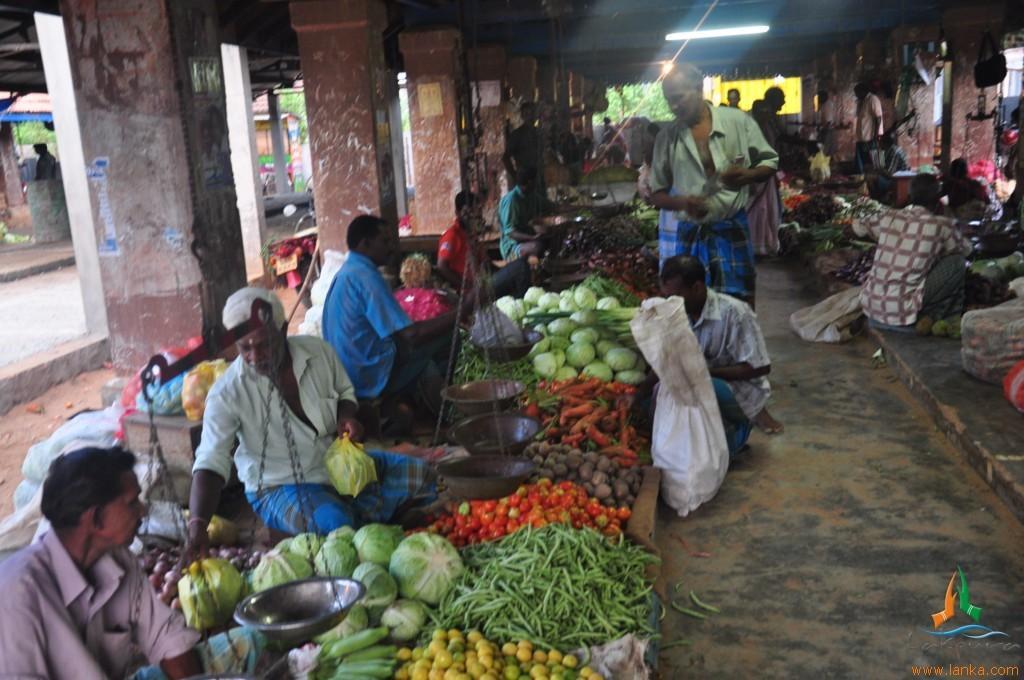Can you describe this image briefly? In the image there is an air flea market with many people selling various vegetables on either side and few persons standing in the middle of the path and there are lights over the ceiling. 